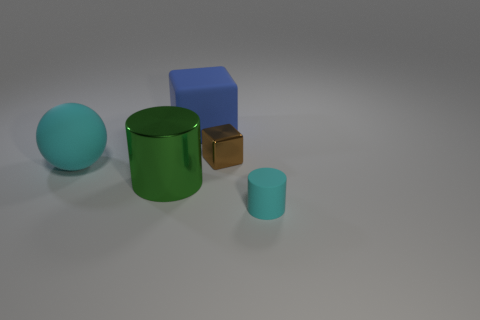Add 1 big gray cubes. How many objects exist? 6 Subtract all cubes. How many objects are left? 3 Add 5 small gray cylinders. How many small gray cylinders exist? 5 Subtract 0 red balls. How many objects are left? 5 Subtract all small blue rubber spheres. Subtract all green cylinders. How many objects are left? 4 Add 2 big cyan rubber balls. How many big cyan rubber balls are left? 3 